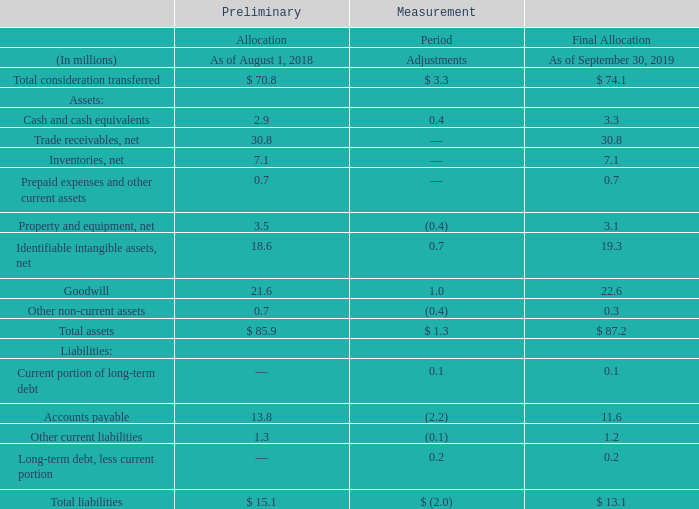Acquisition of AFP
On August 1, 2018, the Company acquired AFP, Inc., a privately held fabricator of foam, corrugated, molded pulp and wood packaging solutions, to join its Product Care division. This acquisition expands our protective packaging offerings in the electronic, transportation and industrial markets with custom engineered applications. We acquired 100% of AFP shares for an estimated consideration of $74.1 million, excluding $3.3 million of cash acquired.
The following table summarizes the consideration transferred to acquire AFP and the final allocation of the purchase price among the assets acquired and liabilities assumed.
What company was acquired in 2018? Afp, inc. What does this table show? The following table summarizes the consideration transferred to acquire afp and the final allocation of the purchase price among the assets acquired and liabilities assumed. What is the adjustment in assets between August 1, 2018 and September 30, 2019?
Answer scale should be: million. $ 3.3. What is the liability to asset ratio as of August 1, 2018?
Answer scale should be: percent. 15.1/85.9
Answer: 17.58. What is the difference between the liability to asset ratio from As of August 1, 2018 to As of September 30, 2019?
Answer scale should be: percent. (15.1/85.9)-(13.1/87.2)
Answer: 2.56. What is the adjustment of total liabilities expressed as a percentage of total liabilities as of August 1, 2018?
Answer scale should be: percent. -2.0/15.1
Answer: -13.25. 